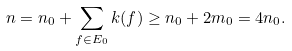<formula> <loc_0><loc_0><loc_500><loc_500>n = n _ { 0 } + \sum _ { f \in E _ { 0 } } k ( f ) \geq n _ { 0 } + 2 m _ { 0 } = 4 n _ { 0 } .</formula> 